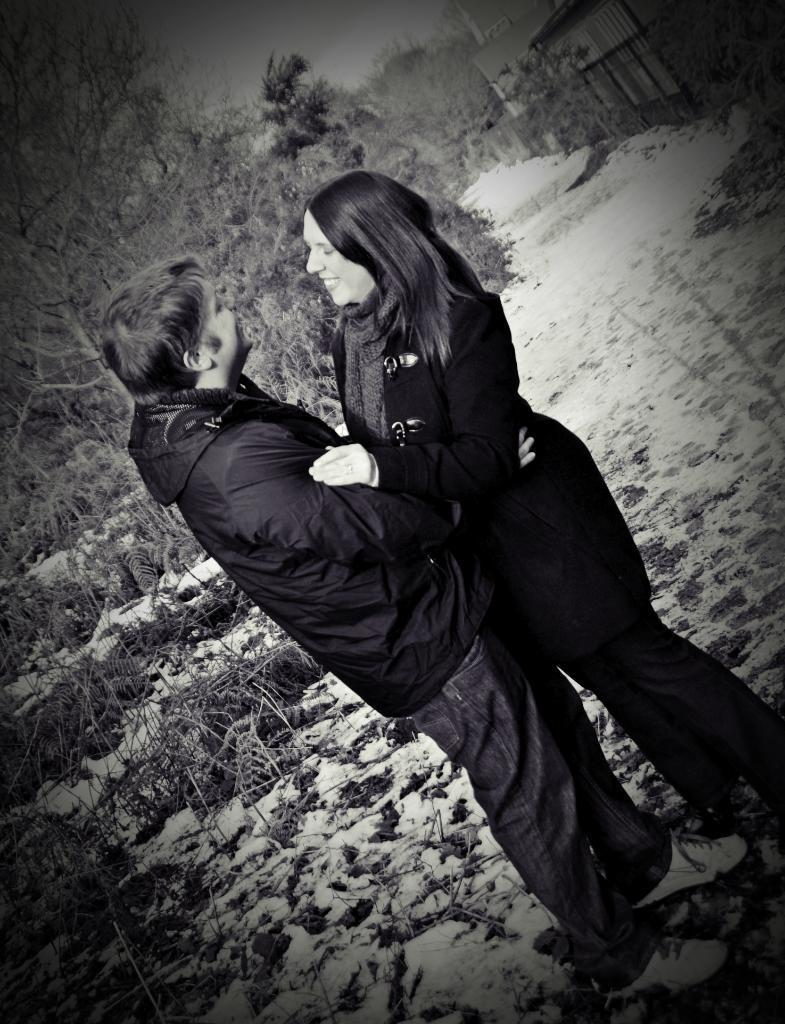How many people are present in the image? There are two people, a man and a woman, present in the image. What are the expressions of the people in the image? The man and the woman are both smiling. What can be seen in the background of the image? There are trees, a fence, a building, and the sky visible in the background of the image. What is the ground made of in the image? The ground is not specified in the image, but it appears to be a solid surface. What type of snow can be seen falling in the image? There is no snow present in the image; it features a man and a woman standing on the ground with a background of trees, a fence, a building, and the sky. 